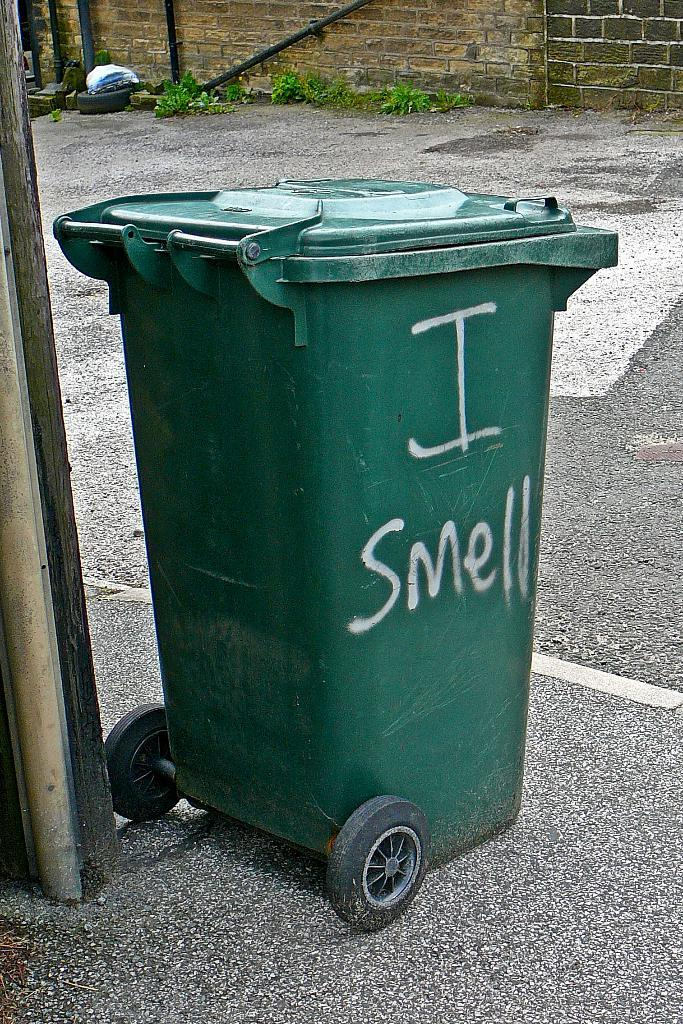<image>
Create a compact narrative representing the image presented. A green trash can with the words "I Smell" sits on a street. 